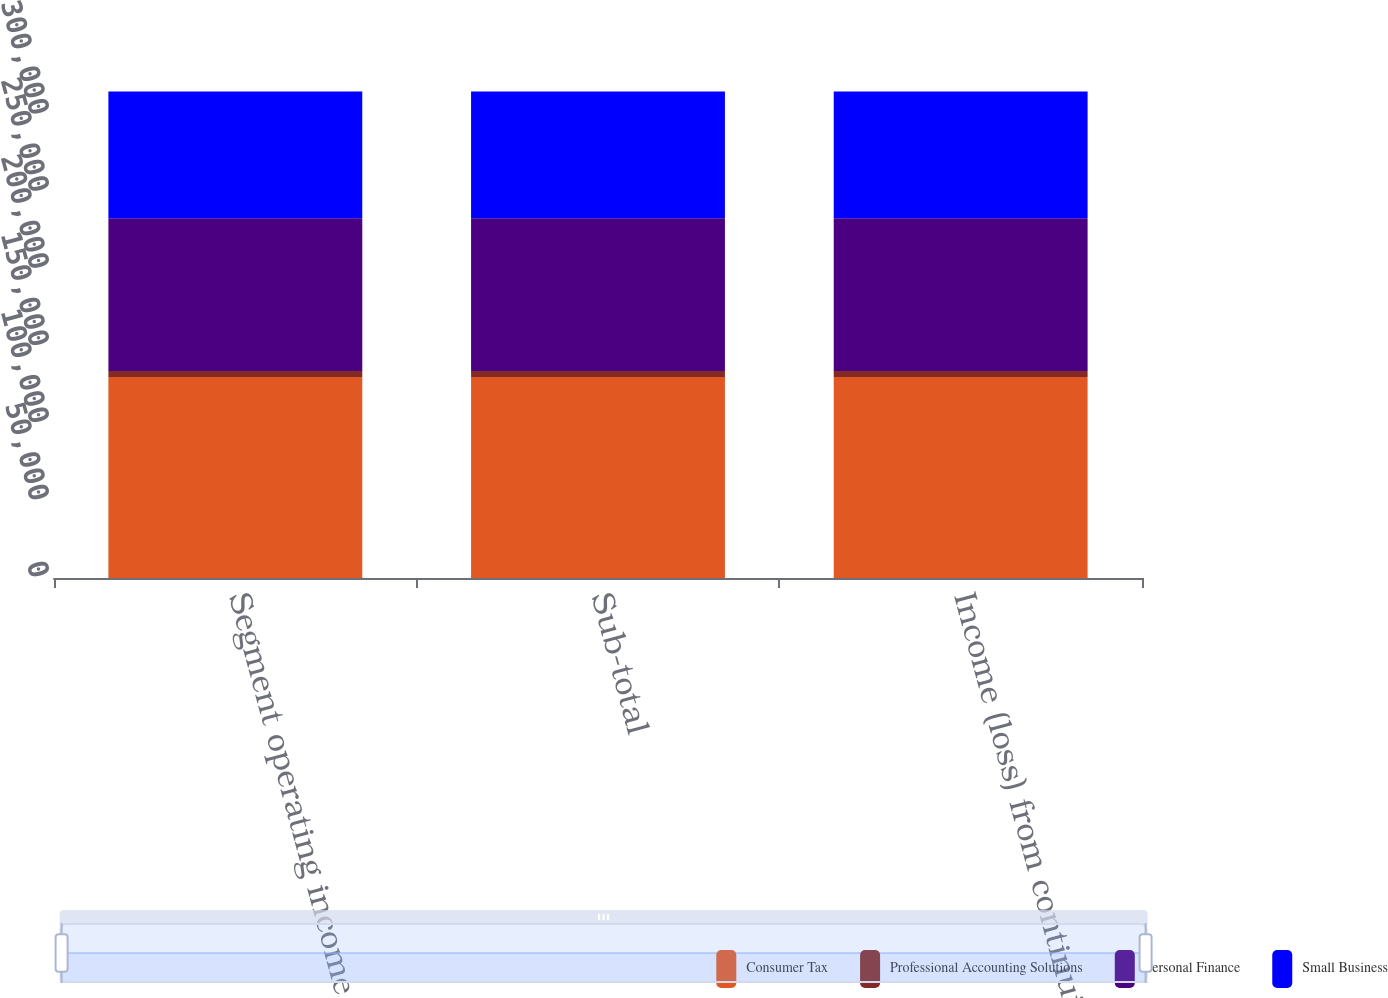<chart> <loc_0><loc_0><loc_500><loc_500><stacked_bar_chart><ecel><fcel>Segment operating income<fcel>Sub-total<fcel>Income (loss) from continuing<nl><fcel>Consumer Tax<fcel>130280<fcel>130280<fcel>130280<nl><fcel>Professional Accounting Solutions<fcel>3878<fcel>3878<fcel>3878<nl><fcel>Personal Finance<fcel>99032<fcel>99032<fcel>99032<nl><fcel>Small Business<fcel>82092<fcel>82092<fcel>82092<nl></chart> 